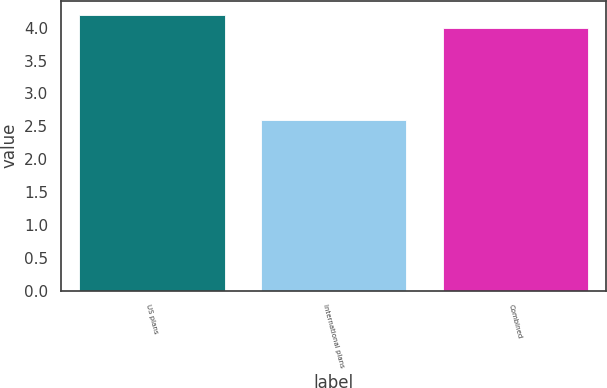Convert chart to OTSL. <chart><loc_0><loc_0><loc_500><loc_500><bar_chart><fcel>US plans<fcel>International plans<fcel>Combined<nl><fcel>4.2<fcel>2.6<fcel>4<nl></chart> 